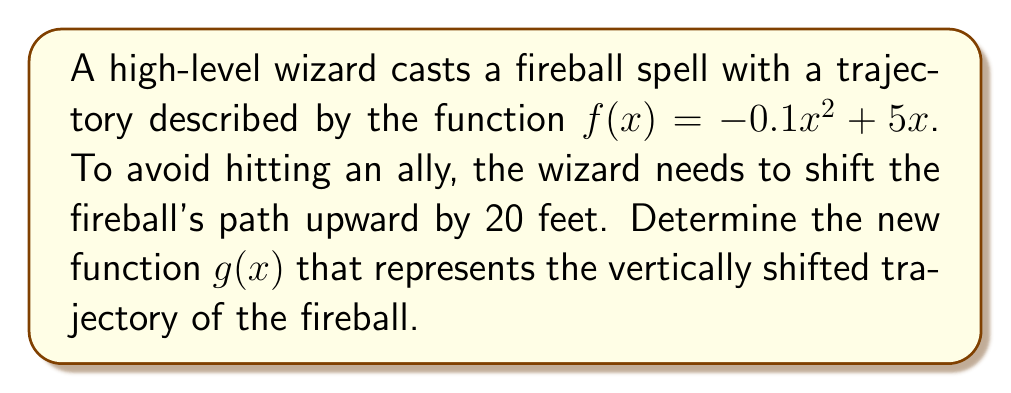Show me your answer to this math problem. To vertically shift a function, we add a constant value to the original function. In this case, we need to shift the function upward by 20 feet.

Step 1: Identify the original function.
$f(x) = -0.1x^2 + 5x$

Step 2: Add the vertical shift value to the function.
To shift the function upward by 20 feet, we add 20 to the original function:
$g(x) = f(x) + 20$

Step 3: Substitute the original function into the equation.
$g(x) = (-0.1x^2 + 5x) + 20$

Step 4: Simplify the equation.
$g(x) = -0.1x^2 + 5x + 20$

This new function $g(x)$ represents the fireball's trajectory shifted 20 feet upward.
Answer: $g(x) = -0.1x^2 + 5x + 20$ 